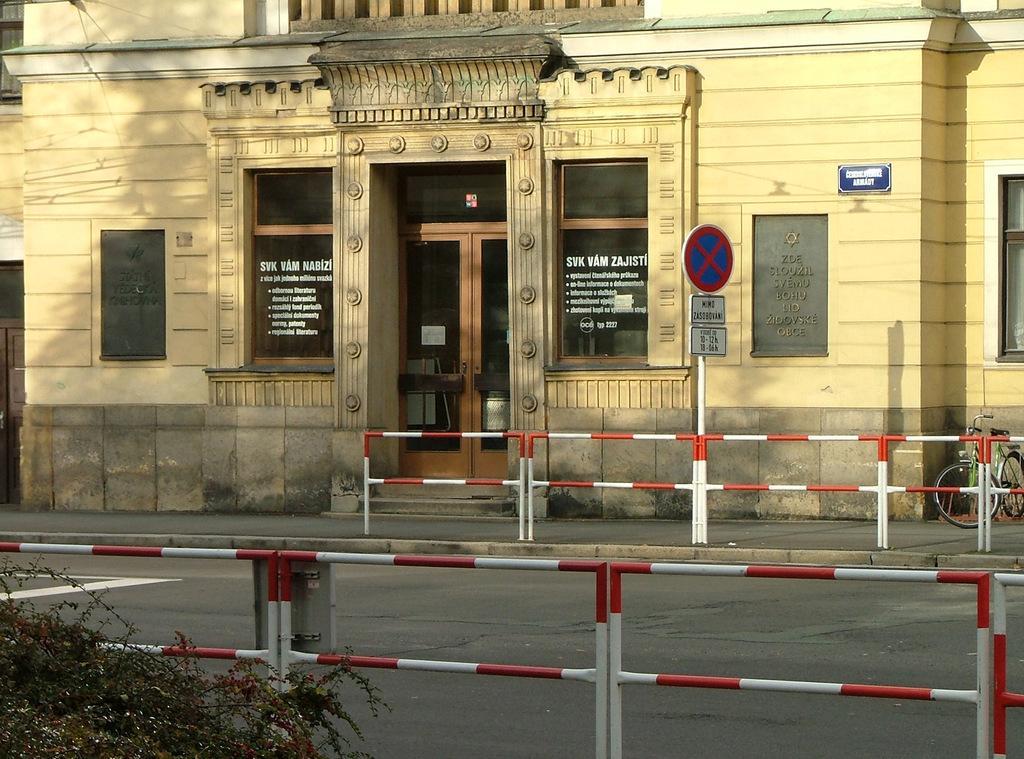How would you summarize this image in a sentence or two? In this image we can see a building. There is some text written on the glasses of the building. There is a bicycle at the right side of the image. There is a sign board in the image. We can see a board on the wall of the building. There are few barriers in the image. There is a plant at the leftmost bottom of the image. 